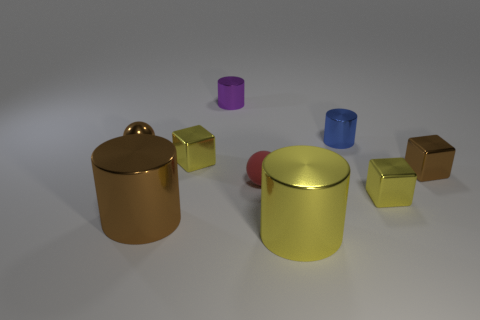Are there any other things that have the same material as the red sphere? Indeed, the material of the red sphere appears to be similar to that of other objects in the scene. Specifically, the golden-colored cubes share a reflective surface characteristic of the red sphere, suggesting they are made from a material with similar properties, such as a polished metal or a material with a metallic finish. 